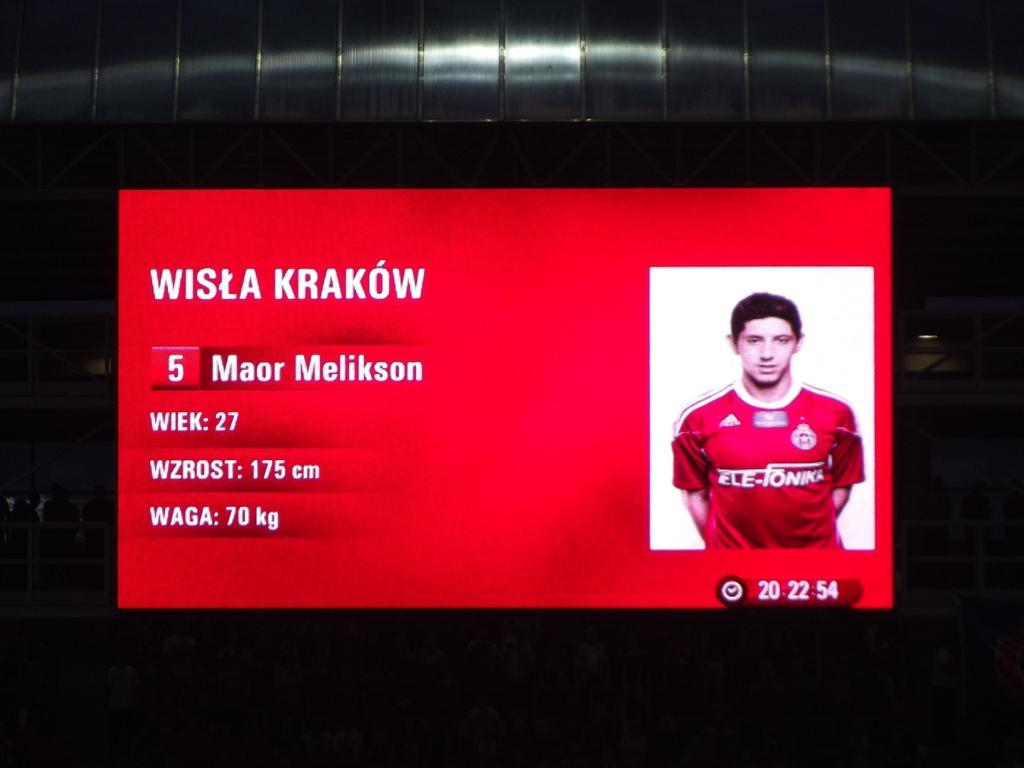<image>
Present a compact description of the photo's key features. Wista Krakow's stats are shown on a large red board 